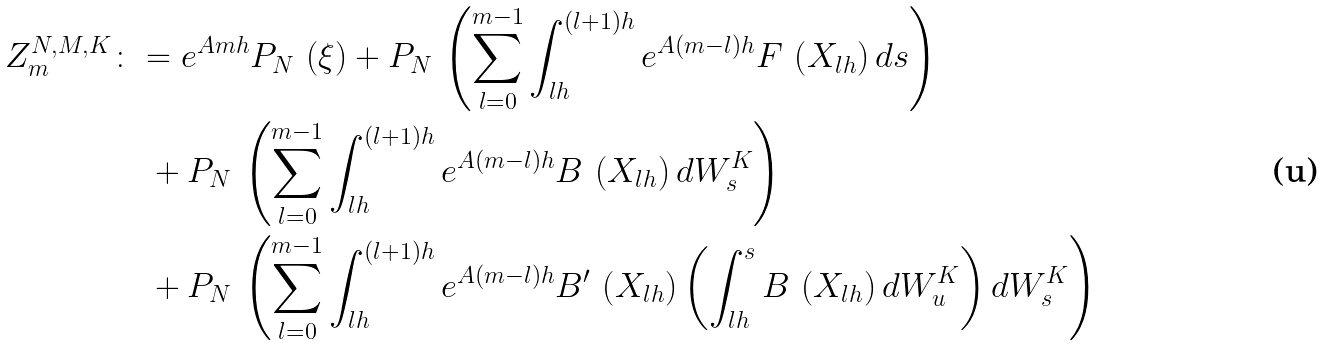<formula> <loc_0><loc_0><loc_500><loc_500>Z _ { m } ^ { N , M , K } & \colon = e ^ { A m h } P _ { N } \, \left ( \xi \right ) + P _ { N } \, \left ( \sum _ { l = 0 } ^ { m - 1 } \int _ { l h } ^ { ( l + 1 ) h } e ^ { A ( m - l ) h } F \, \left ( X _ { l h } \right ) d s \right ) \\ & \quad + P _ { N } \, \left ( \sum _ { l = 0 } ^ { m - 1 } \int _ { l h } ^ { ( l + 1 ) h } e ^ { A ( m - l ) h } B \, \left ( X _ { l h } \right ) d W _ { s } ^ { K } \right ) \\ & \quad + P _ { N } \, \left ( \sum _ { l = 0 } ^ { m - 1 } \int _ { l h } ^ { ( l + 1 ) h } e ^ { A ( m - l ) h } B ^ { \prime } \, \left ( X _ { l h } \right ) \left ( \int _ { l h } ^ { s } B \, \left ( X _ { l h } \right ) d W _ { u } ^ { K } \right ) d W _ { s } ^ { K } \right )</formula> 